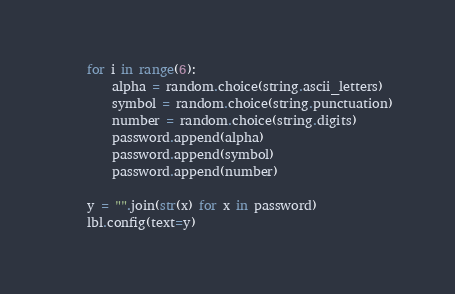Convert code to text. <code><loc_0><loc_0><loc_500><loc_500><_Python_>    for i in range(6):
        alpha = random.choice(string.ascii_letters)
        symbol = random.choice(string.punctuation)
        number = random.choice(string.digits)
        password.append(alpha)
        password.append(symbol)
        password.append(number)

    y = "".join(str(x) for x in password)
    lbl.config(text=y)
</code> 